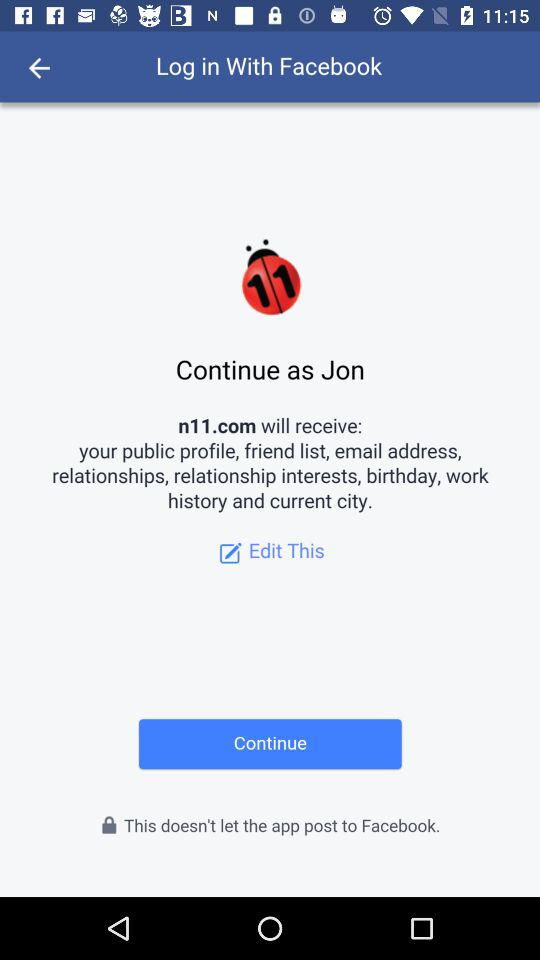What application is asking for permission? The application asking for permission is "n11.com". 